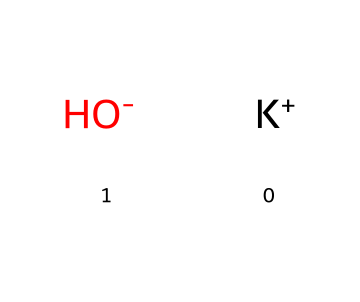What is the molecular formula of this chemical? The chemical structure consists of one potassium ion (K+) and one hydroxide ion (OH-). Therefore, the molecular formula is derived from the presence of these two components.
Answer: KOH How many atoms are present in this chemical? The structure includes one potassium atom and one oxygen atom in the hydroxide ion and one hydrogen atom, giving a total of three atoms. The counting is: 1 potassium + 1 oxygen + 1 hydrogen = 3.
Answer: 3 What type of ion is represented by K+? The K+ in the structure represents a cation, which is a positively charged ion. In this case, potassium is a metal that loses one electron to form a positive charge.
Answer: cation What role does OH- play in the chemical's properties? The OH- indicates the presence of a hydroxide ion, which is responsible for the basic properties of the substance. Hydroxide ions contribute to the strong alkalinity of this compound, typical in superbases.
Answer: basic Is potassium hydroxide a strong base? The structure signifies that potassium hydroxide dissociates fully in water, indicating strong basicity; thus, being a strong base is characteristic of this compound.
Answer: yes How does the presence of K+ and OH- affect water solubility? The presence of both K+ (potassium cation) and OH- (hydroxide anion) results in high solubility in water due to the ionic nature of these species, which allows them to dissociate easily in solvent.
Answer: high What type of chemical reaction can potassium hydroxide participate in? Potassium hydroxide can participate in neutralization reactions, where it reacts with acids to form water and a salt due to its basic nature (from OH-).
Answer: neutralization 